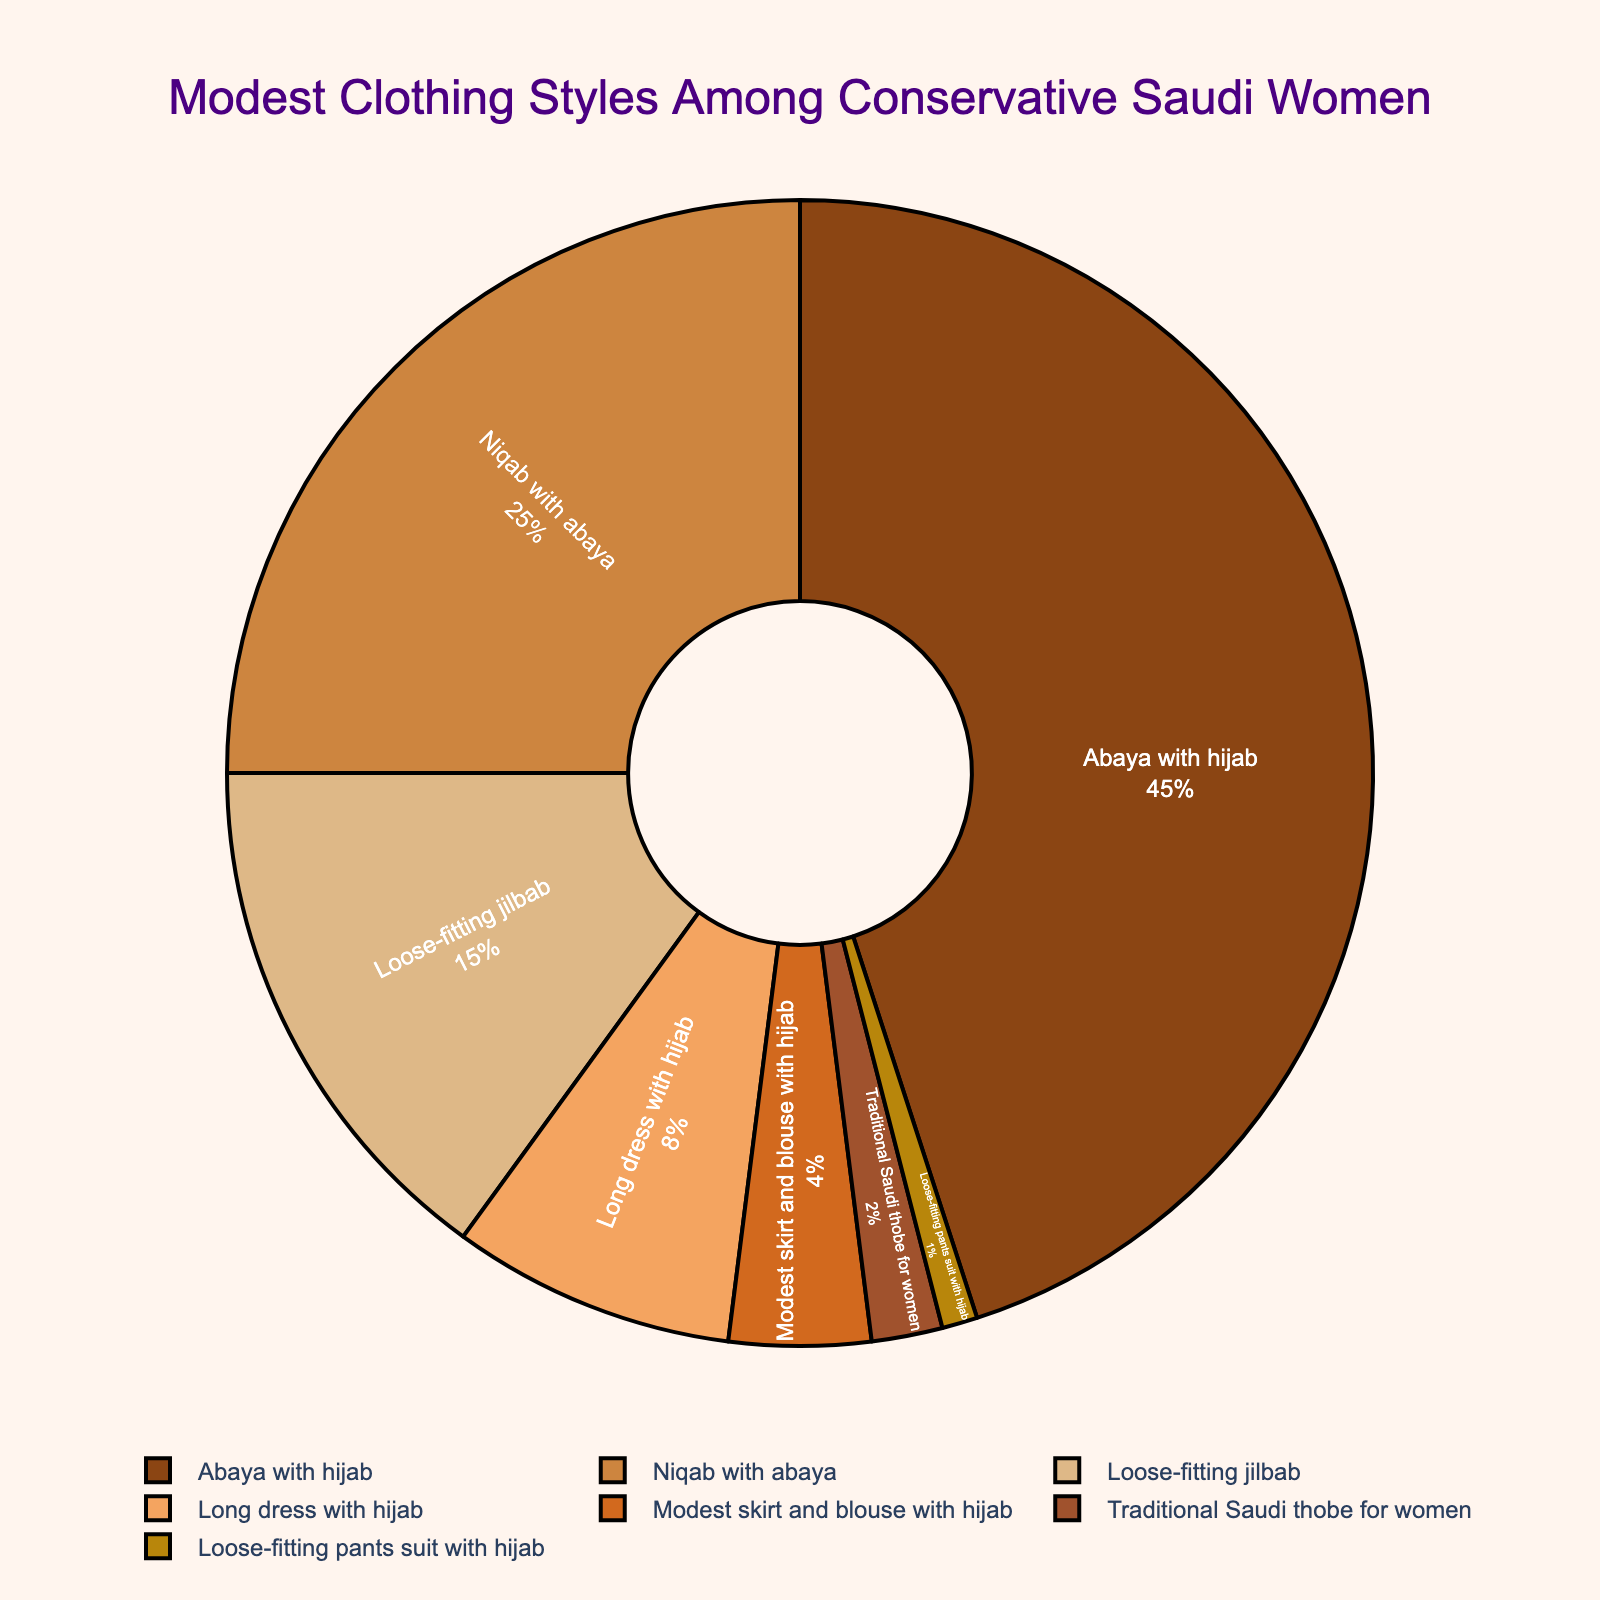What's the most popular modest clothing style among conservative Saudi women? By looking at the pie chart, the section representing 'Abaya with hijab' is the largest. This style constitutes the highest percentage of all the clothing styles.
Answer: Abaya with hijab Which clothing style is the second most popular after 'Abaya with hijab'? The pie chart shows that 'Niqab with abaya' is the second largest section after 'Abaya with hijab', indicating it is the second most popular style.
Answer: Niqab with abaya How does the proportion of 'Loose-fitting jilbab' compare to 'Long dress with hijab'? The pie chart shows 'Loose-fitting jilbab' occupies 15% of the chart while 'Long dress with hijab' occupies 8%. Therefore, 'Loose-fitting jilbab' is nearly twice as popular as 'Long dress with hijab'.
Answer: 'Loose-fitting jilbab' is nearly twice as popular as 'Long dress with hijab' What is the combined percentage of 'Abaya with hijab' and 'Niqab with abaya'? 'Abaya with hijab' is 45% and 'Niqab with abaya' is 25%. Adding these two percentages together gives 45 + 25 = 70%.
Answer: 70% Which style represents the smallest percentage of the total? The smallest section in the pie chart represents the 'Loose-fitting pants suit with hijab', making up 1% of the total.
Answer: Loose-fitting pants suit with hijab What percentage of women wear either 'Modest skirt and blouse with hijab' or 'Traditional Saudi thobe for women'? The pie chart shows 'Modest skirt and blouse with hijab' is 4% and 'Traditional Saudi thobe for women' is 2%. Adding these together gives 4 + 2 = 6%.
Answer: 6% By how much does the 'Long dress with hijab' percentage exceed the 'Modest skirt and blouse with hijab' percentage? 'Long dress with hijab' is 8% while 'Modest skirt and blouse with hijab' is 4%. The difference is 8 - 4 = 4%.
Answer: 4% What is the total percentage of styles that include a hijab? The styles with hijab are 'Abaya with hijab' (45%), 'Long dress with hijab' (8%), 'Modest skirt and blouse with hijab' (4%), and 'Loose-fitting pants suit with hijab' (1%). Adding these percentages gives 45 + 8 + 4 + 1 = 58%.
Answer: 58% What is the ratio of 'Niqab with abaya' to 'Loose-fitting jilbab'? 'Niqab with abaya' is 25% and 'Loose-fitting jilbab' is 15%. The ratio is 25:15, which simplifies to 5:3.
Answer: 5:3 